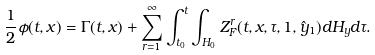Convert formula to latex. <formula><loc_0><loc_0><loc_500><loc_500>\frac { 1 } { 2 } \phi ( t , x ) = \Gamma ( t , x ) + \sum _ { r = 1 } ^ { \infty } \int _ { t _ { 0 } } ^ { t } \int _ { H _ { 0 } } Z ^ { r } _ { F } ( t , x , \tau , 1 , \hat { y } _ { 1 } ) d H _ { y } d \tau .</formula> 